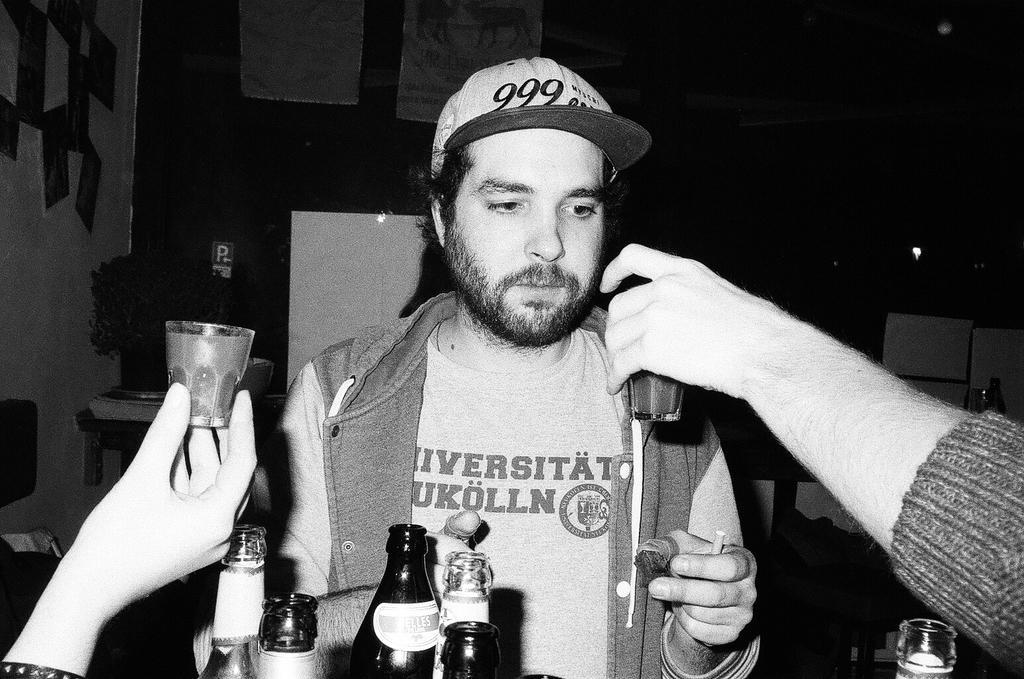In one or two sentences, can you explain what this image depicts? There is a man in the center and he is holding something in his hand. There is a hand on the right side holding a cup. 